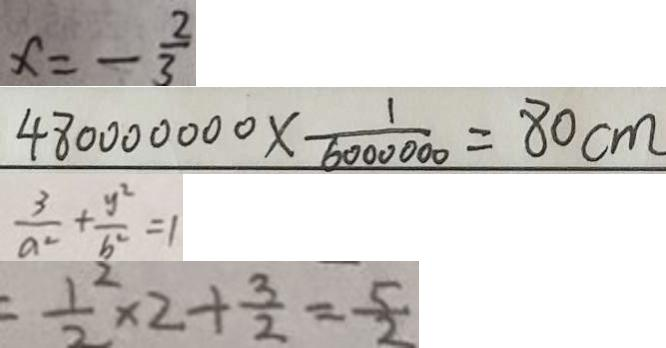Convert formula to latex. <formula><loc_0><loc_0><loc_500><loc_500>x = - \frac { 2 } { 3 } 
 4 8 0 0 0 0 0 0 0 \times \frac { 1 } { 6 0 0 0 0 0 0 } = 8 0 c m 
 \frac { 3 } { a ^ { 2 } } + \frac { y ^ { 2 } } { b ^ { 2 } } = 1 
 = \frac { 1 } { 2 } ^ { 2 } \times 2 + \frac { 3 } { 2 } = \frac { 5 } { 2 }</formula> 